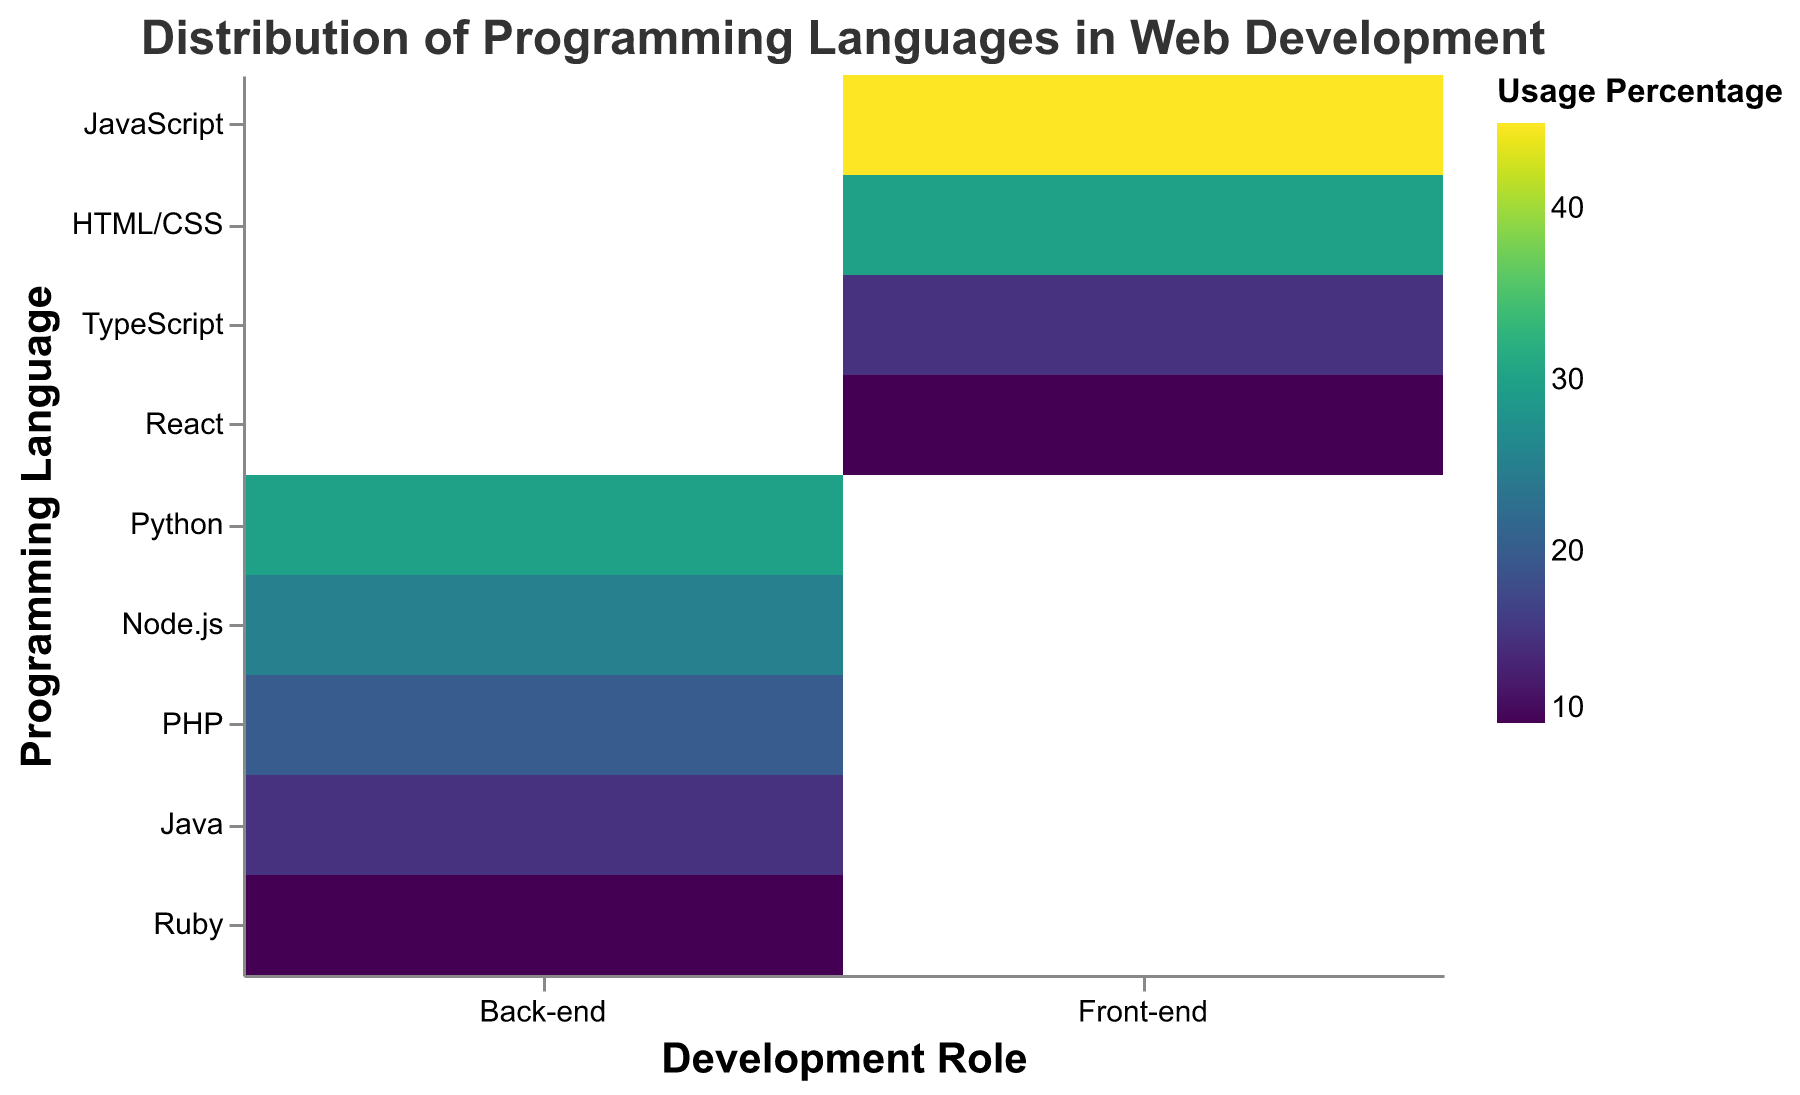Which development role has the highest usage percentage for a single language? Look at the colors representing usage percentages; the darkest color represents the highest percentage. The darkest color is for JavaScript in the Front-end role, with 45%.
Answer: Front-end What is the combined percentage of usage for HTML/CSS and TypeScript in Front-end development? HTML/CSS has a usage percentage of 30%, and TypeScript has 15%. The combined percentage is 30% + 15% = 45%.
Answer: 45% Which Back-end language has the lowest usage percentage? Look at the lightest color in the Back-end role; Ruby shows the lightest color with a usage percentage of 10%.
Answer: Ruby Compare the usage of Java and Python in Back-end roles. Which is greater, and by how much? Python has a usage percentage of 30%, while Java has 15%. The difference is 30% - 15% = 15%. Python is greater by 15%.
Answer: Python by 15% What is the difference in usage percentage between JavaScript in Front-end and Node.js in Back-end? JavaScript has a usage of 45% in Front-end, and Node.js has a usage of 25% in Back-end. The difference is 45% - 25% = 20%.
Answer: 20% What is the sum of usage percentages for all languages in the Back-end role? Sum up the percentages for Python (30%), Node.js (25%), PHP (20%), Java (15%), and Ruby (10%): 30% + 25% + 20% + 15% + 10% = 100%.
Answer: 100% Which language is shared between Front-end and Back-end, considering the role names from the data? From the data, each language is specifically either Front-end or Back-end without overlap. No language appears in both roles.
Answer: None How do HTML/CSS and React compare in their percentage usage in Front-end roles? Which one has higher usage? HTML/CSS has 30%, and React has 10%; therefore, HTML/CSS has a higher usage percentage.
Answer: HTML/CSS What percentage of Back-end languages have usage less than 20%? PHP has 20%, and Java and Ruby are below 20% with 15% and 10%, respectively. So, 2 out of 5 languages in the Back-end have usage less than 20%, which is 40%.
Answer: 40% Describe the color usage pattern in representing high and low usage percentages. Higher usage percentages (darker color) are seen in JavaScript (45%), and lower usage percentages (lighter color) are evident in Ruby (10%). Colors get lighter as the percentage decreases.
Answer: Darker for high, lighter for low 